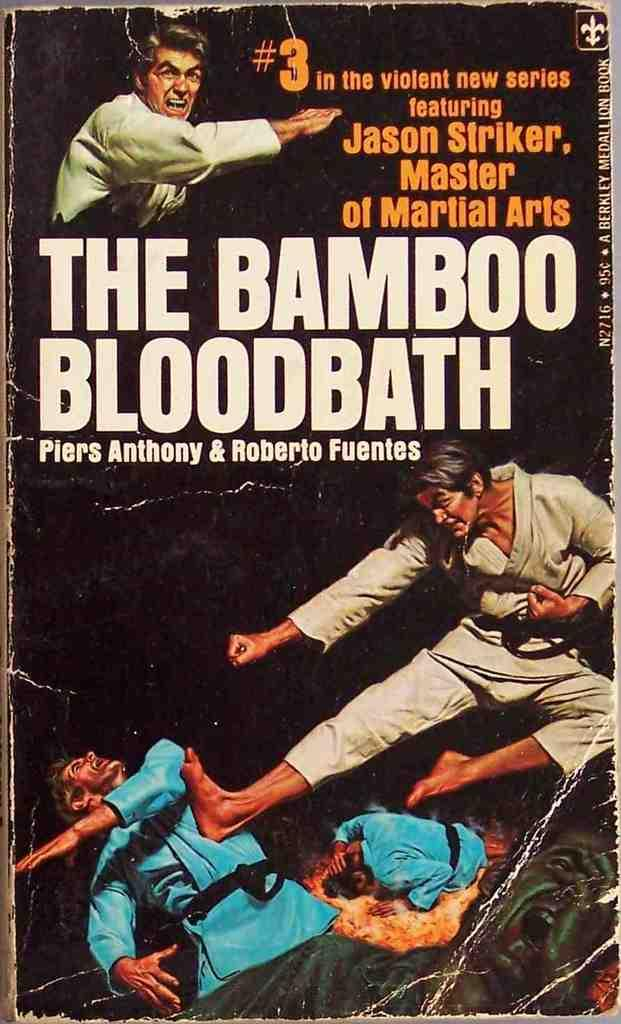What object is the main focus of the image? There is a book in the image. How is the book being displayed in the image? The book is shown from the front view. What can be found on the surface of the book? The book has text on it. Are there any other subjects visible in the image? Yes, there are people visible in the image. What type of vegetable is being used as a bookmark in the image? There is no vegetable being used as a bookmark in the image, as the provided facts do not mention any vegetables or bookmarks. 